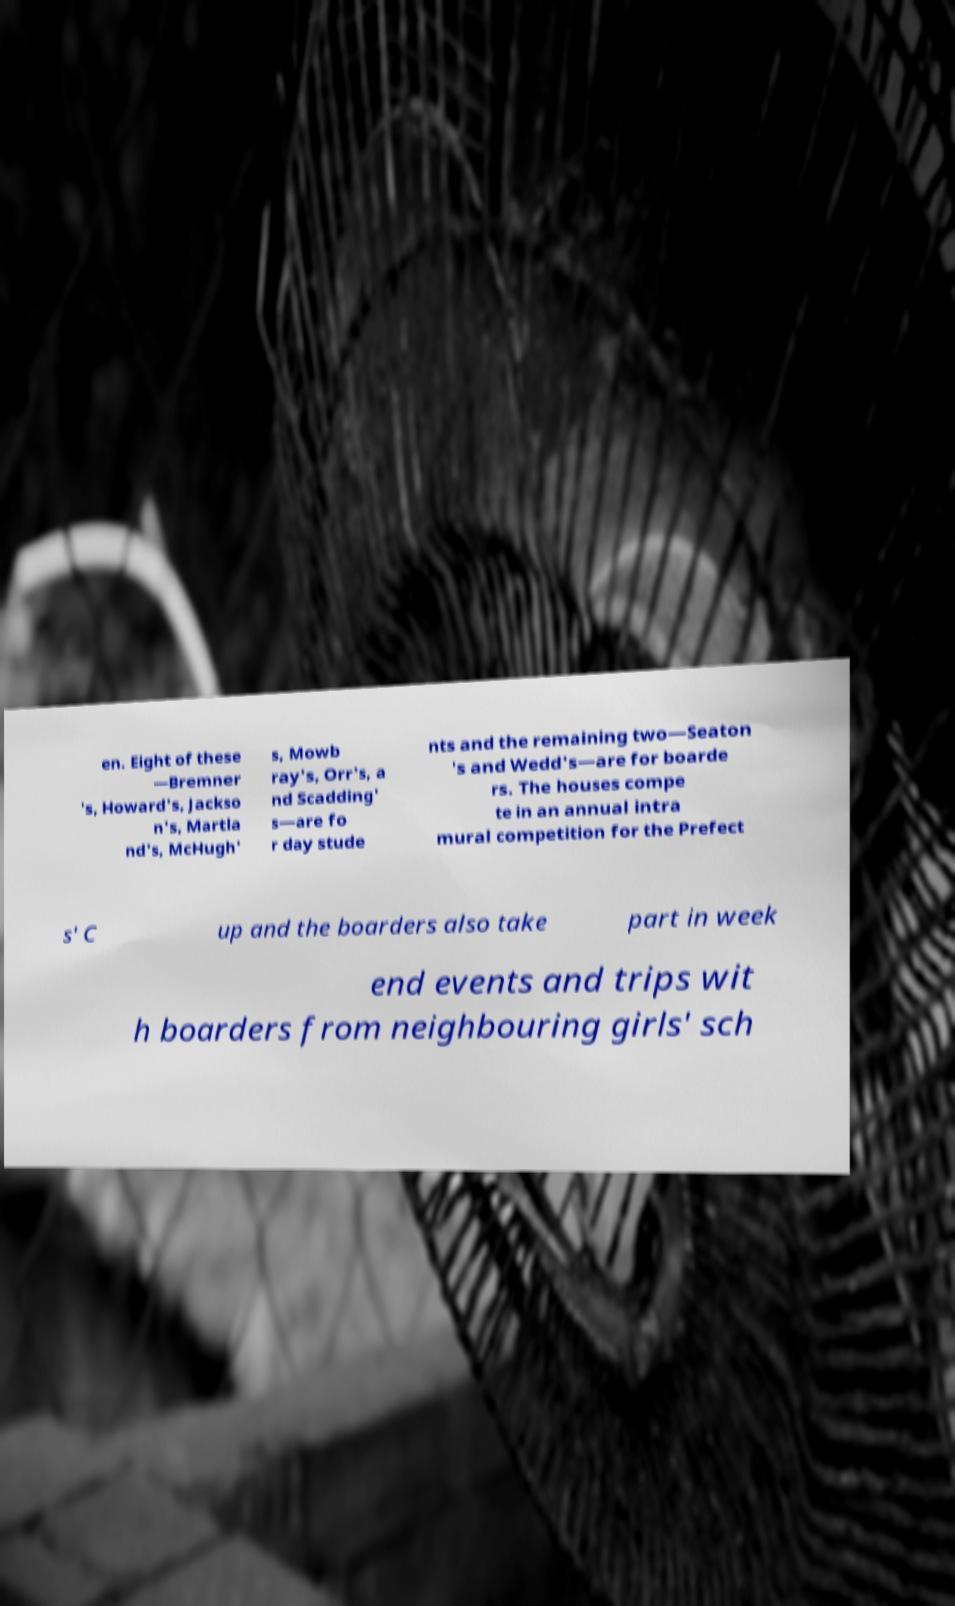Can you accurately transcribe the text from the provided image for me? en. Eight of these —Bremner 's, Howard's, Jackso n's, Martla nd's, McHugh' s, Mowb ray's, Orr's, a nd Scadding' s—are fo r day stude nts and the remaining two—Seaton 's and Wedd's—are for boarde rs. The houses compe te in an annual intra mural competition for the Prefect s' C up and the boarders also take part in week end events and trips wit h boarders from neighbouring girls' sch 